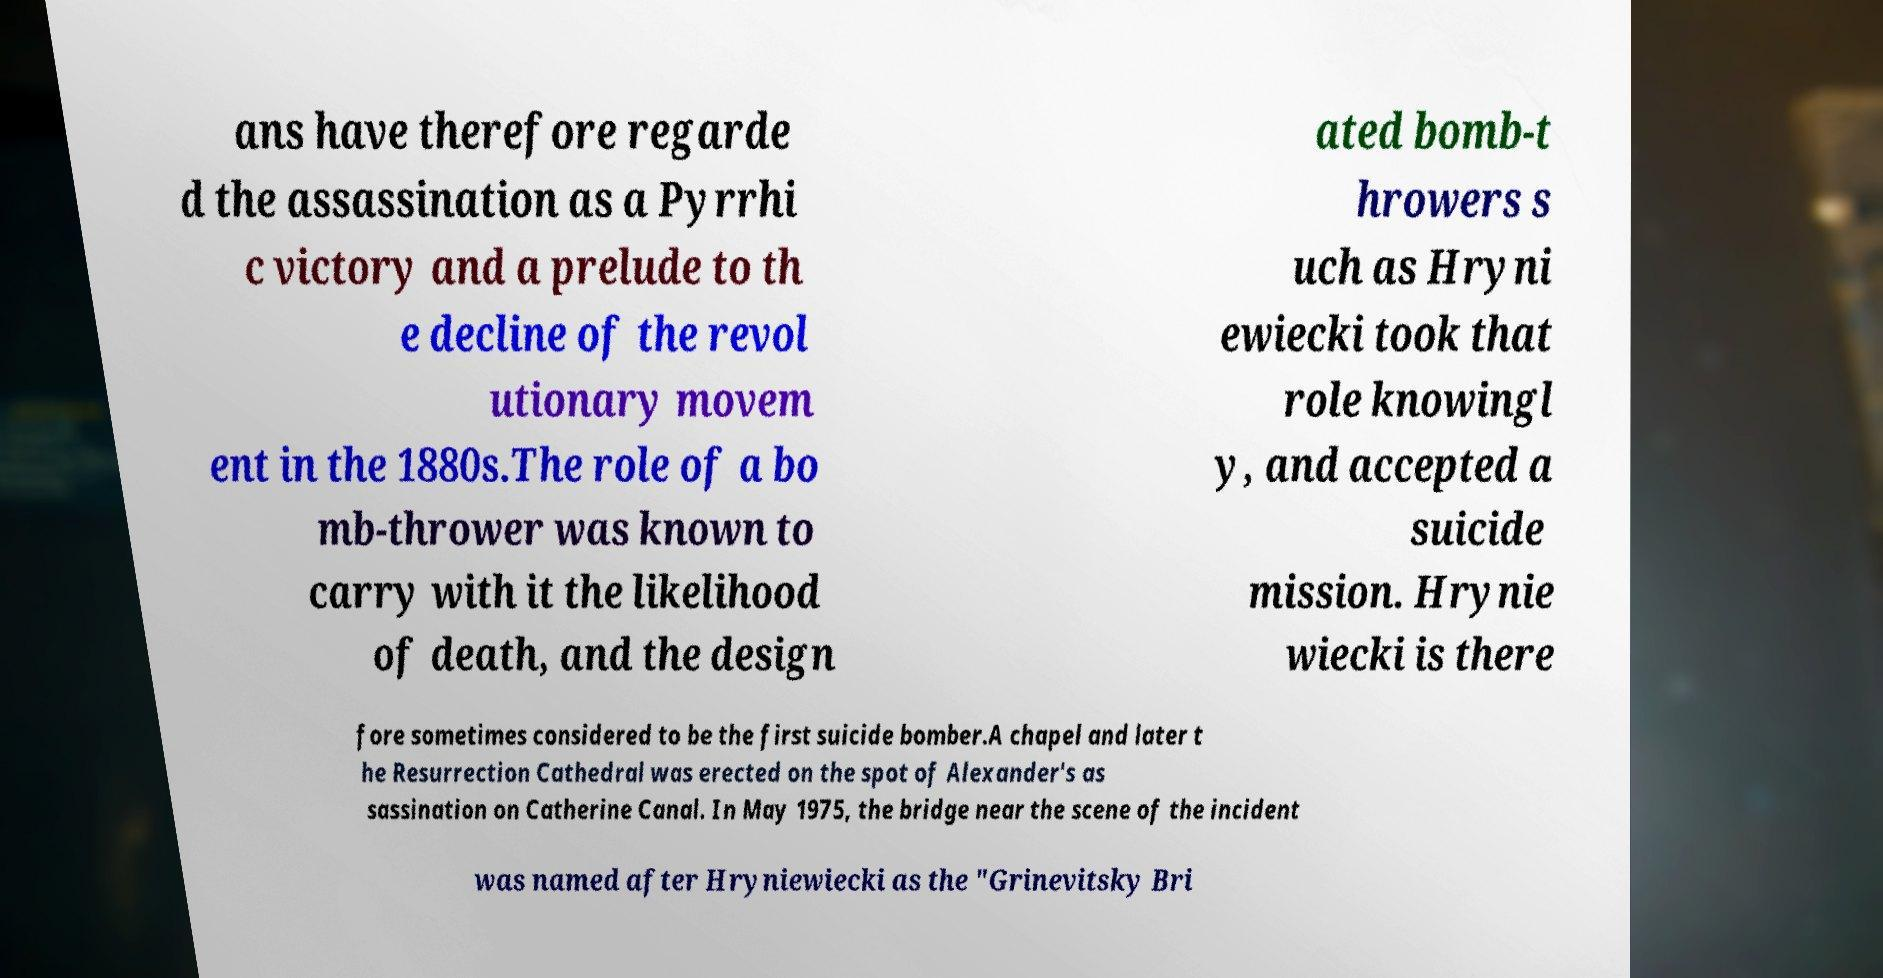Please identify and transcribe the text found in this image. ans have therefore regarde d the assassination as a Pyrrhi c victory and a prelude to th e decline of the revol utionary movem ent in the 1880s.The role of a bo mb-thrower was known to carry with it the likelihood of death, and the design ated bomb-t hrowers s uch as Hryni ewiecki took that role knowingl y, and accepted a suicide mission. Hrynie wiecki is there fore sometimes considered to be the first suicide bomber.A chapel and later t he Resurrection Cathedral was erected on the spot of Alexander's as sassination on Catherine Canal. In May 1975, the bridge near the scene of the incident was named after Hryniewiecki as the "Grinevitsky Bri 